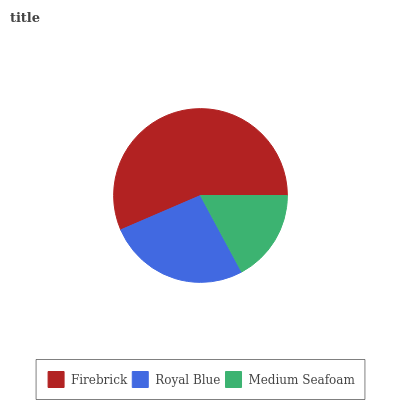Is Medium Seafoam the minimum?
Answer yes or no. Yes. Is Firebrick the maximum?
Answer yes or no. Yes. Is Royal Blue the minimum?
Answer yes or no. No. Is Royal Blue the maximum?
Answer yes or no. No. Is Firebrick greater than Royal Blue?
Answer yes or no. Yes. Is Royal Blue less than Firebrick?
Answer yes or no. Yes. Is Royal Blue greater than Firebrick?
Answer yes or no. No. Is Firebrick less than Royal Blue?
Answer yes or no. No. Is Royal Blue the high median?
Answer yes or no. Yes. Is Royal Blue the low median?
Answer yes or no. Yes. Is Medium Seafoam the high median?
Answer yes or no. No. Is Firebrick the low median?
Answer yes or no. No. 